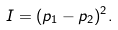<formula> <loc_0><loc_0><loc_500><loc_500>I = ( p _ { 1 } - p _ { 2 } ) ^ { 2 } .</formula> 